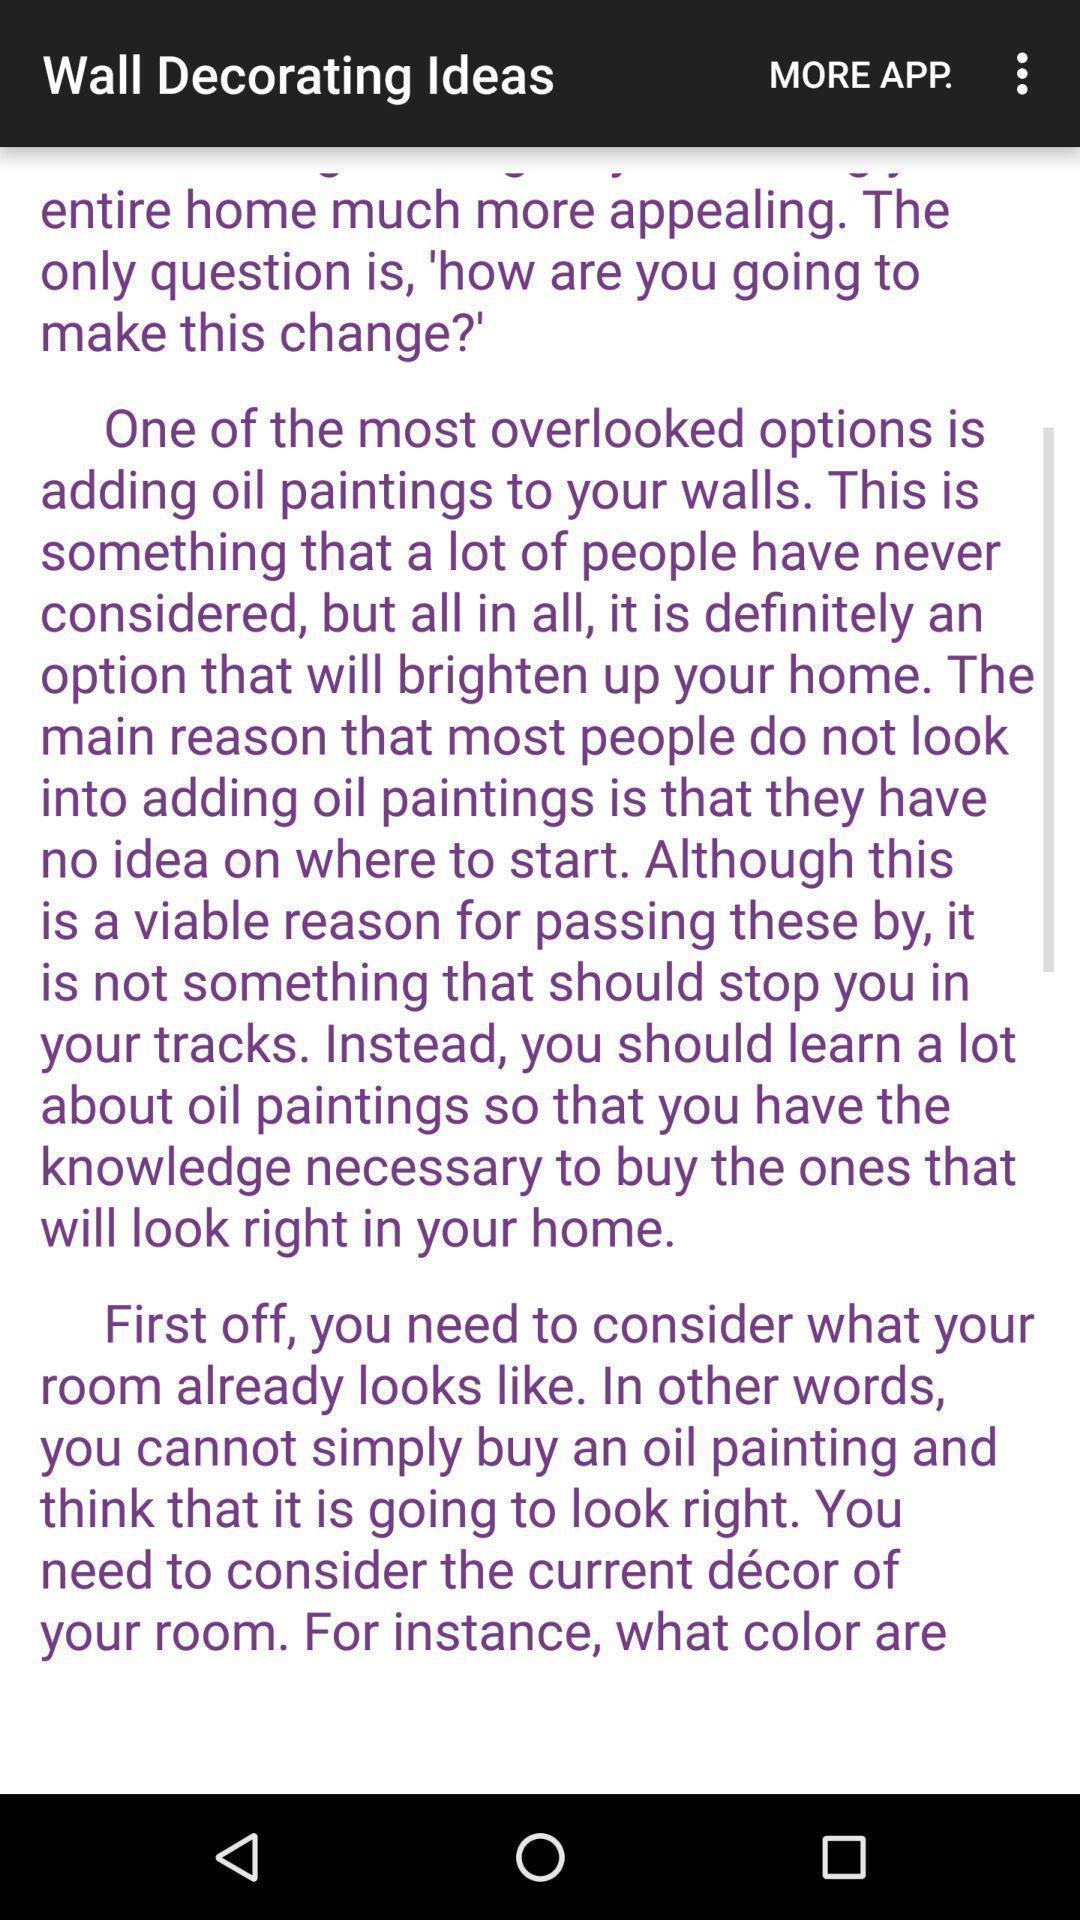What details can you identify in this image? Page showing information about decorating ideas. 